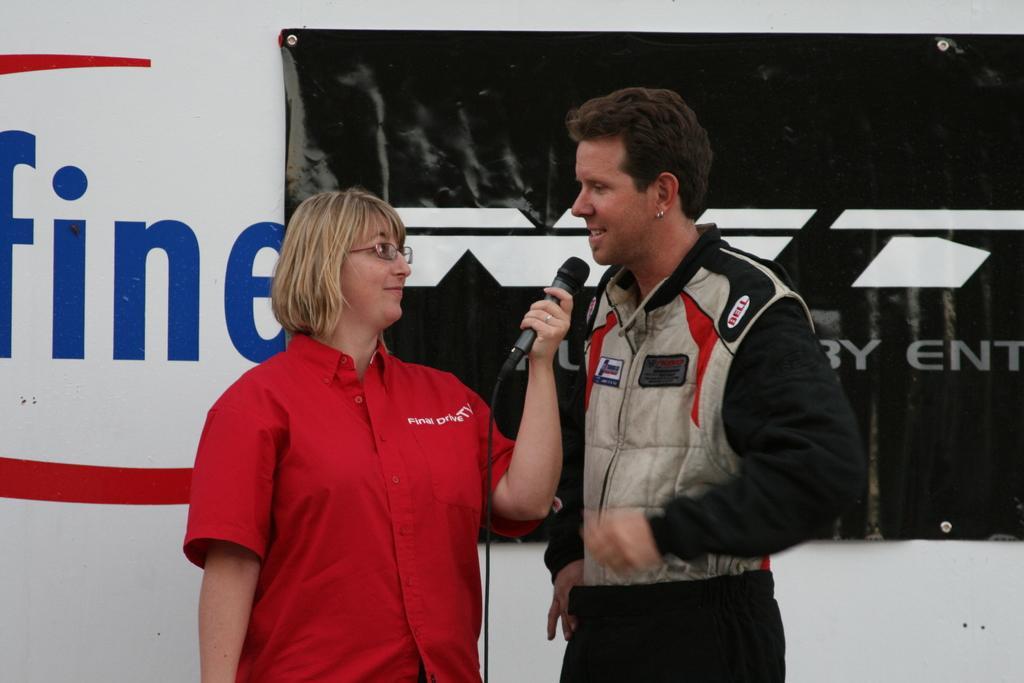Could you give a brief overview of what you see in this image? In this image at front there are two persons standing on the floor where the left side person is holding the mike. At the back side there is a wall with the banner attached to it. 